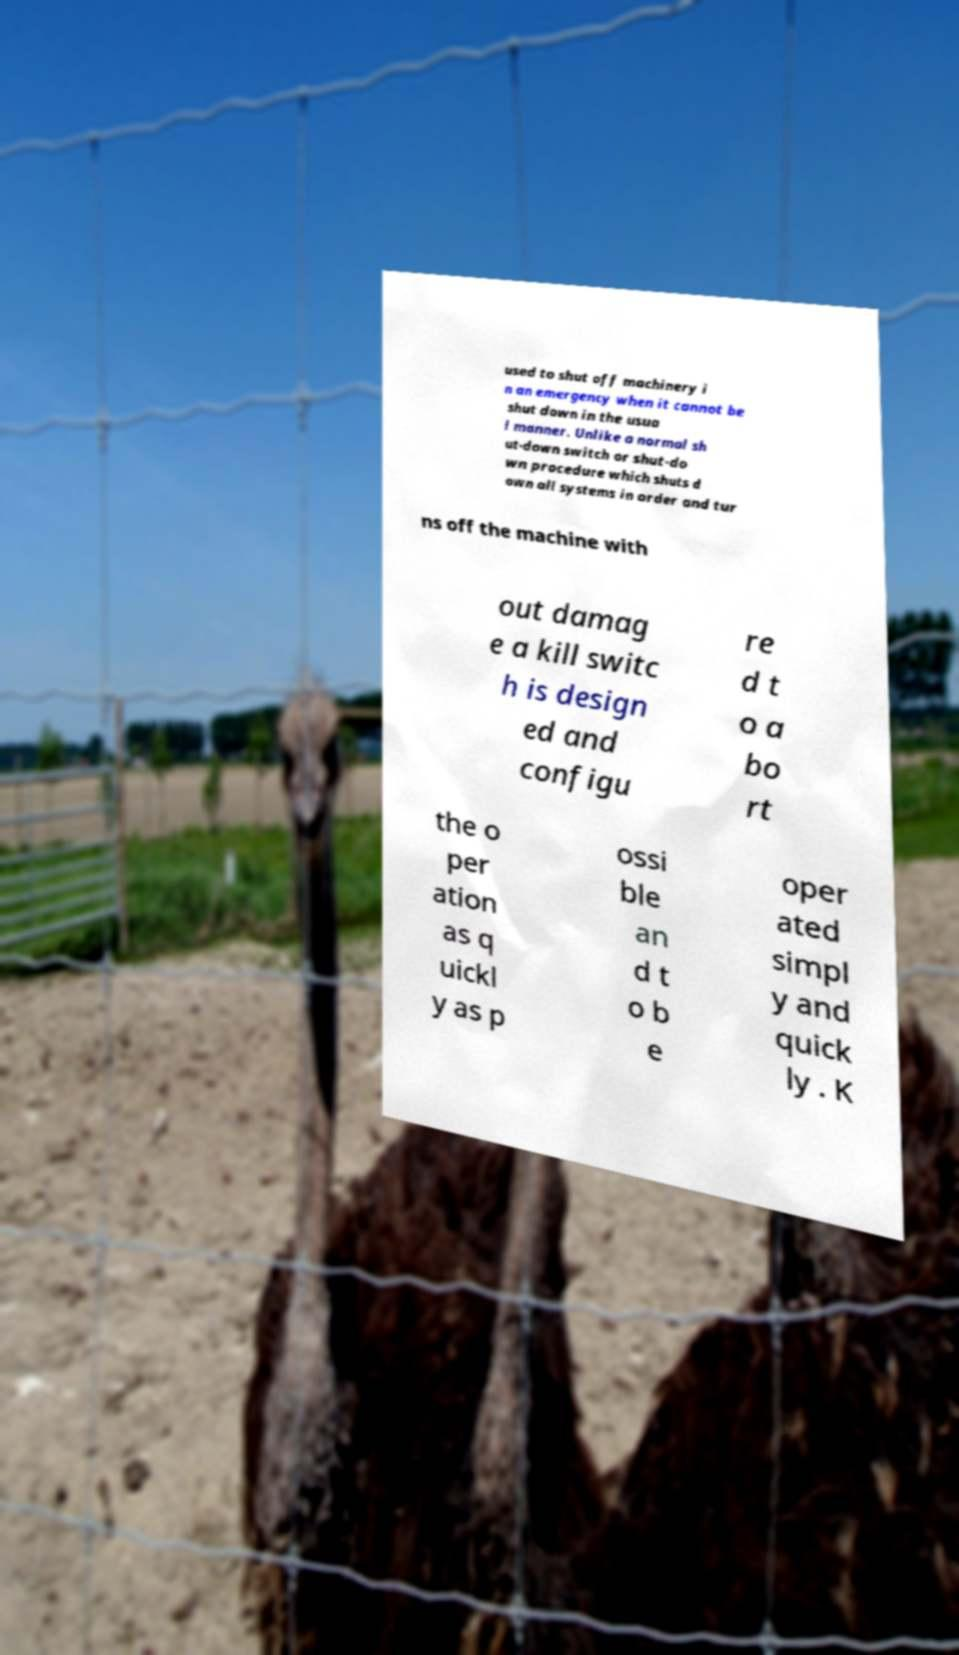For documentation purposes, I need the text within this image transcribed. Could you provide that? used to shut off machinery i n an emergency when it cannot be shut down in the usua l manner. Unlike a normal sh ut-down switch or shut-do wn procedure which shuts d own all systems in order and tur ns off the machine with out damag e a kill switc h is design ed and configu re d t o a bo rt the o per ation as q uickl y as p ossi ble an d t o b e oper ated simpl y and quick ly . K 